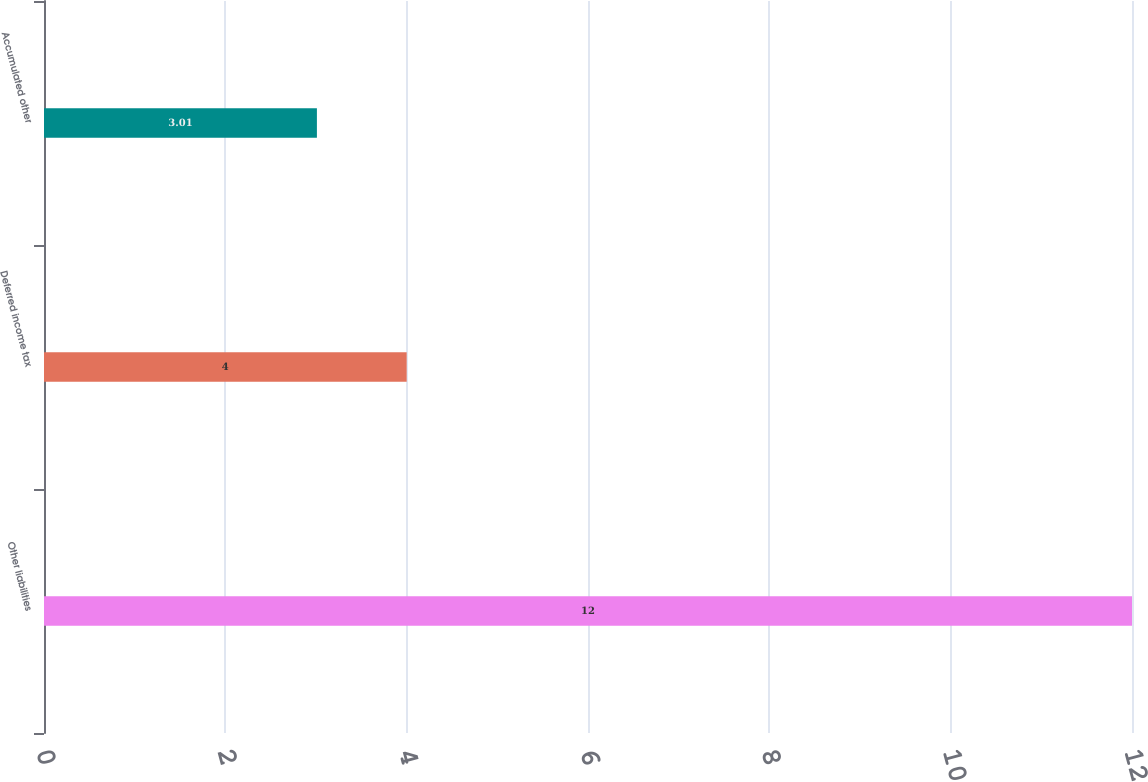Convert chart to OTSL. <chart><loc_0><loc_0><loc_500><loc_500><bar_chart><fcel>Other liabilities<fcel>Deferred income tax<fcel>Accumulated other<nl><fcel>12<fcel>4<fcel>3.01<nl></chart> 